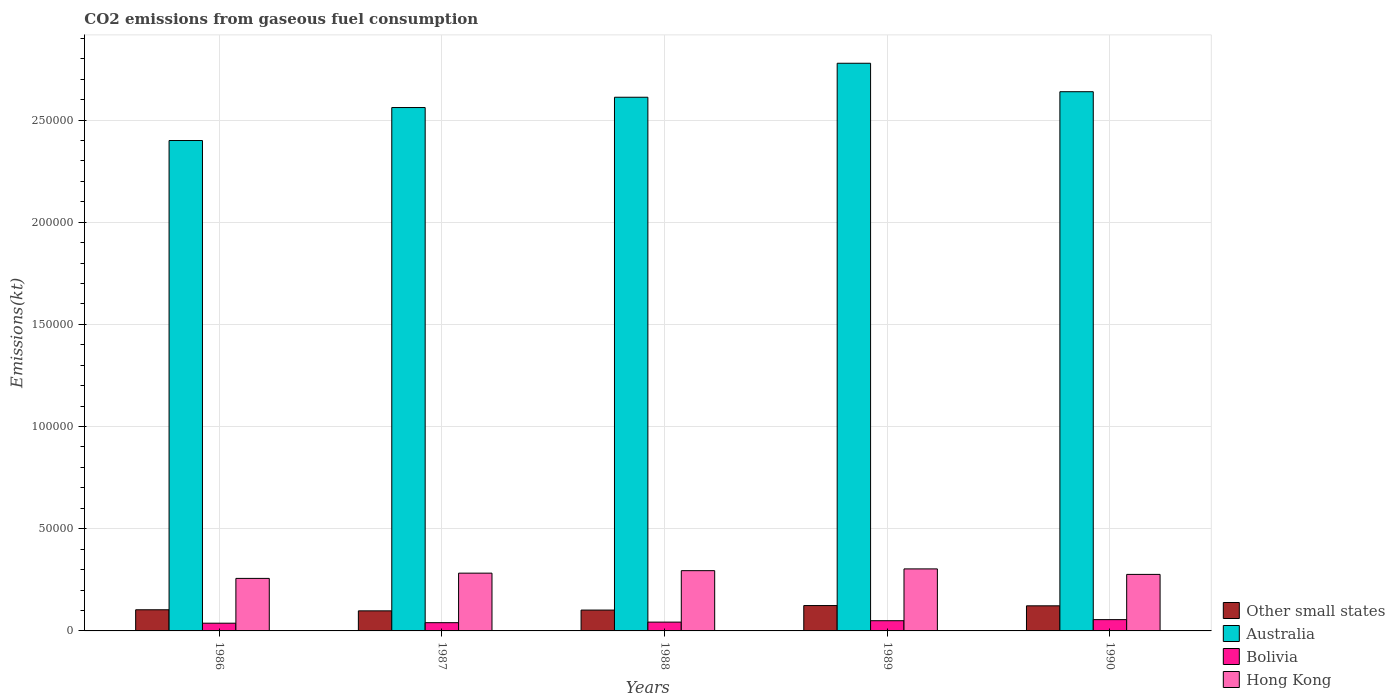How many bars are there on the 4th tick from the left?
Provide a short and direct response. 4. What is the label of the 3rd group of bars from the left?
Offer a very short reply. 1988. In how many cases, is the number of bars for a given year not equal to the number of legend labels?
Provide a short and direct response. 0. What is the amount of CO2 emitted in Bolivia in 1987?
Ensure brevity in your answer.  4030.03. Across all years, what is the maximum amount of CO2 emitted in Bolivia?
Your answer should be compact. 5526.17. Across all years, what is the minimum amount of CO2 emitted in Hong Kong?
Keep it short and to the point. 2.57e+04. In which year was the amount of CO2 emitted in Australia minimum?
Your answer should be compact. 1986. What is the total amount of CO2 emitted in Bolivia in the graph?
Provide a succinct answer. 2.26e+04. What is the difference between the amount of CO2 emitted in Australia in 1987 and that in 1989?
Provide a short and direct response. -2.17e+04. What is the difference between the amount of CO2 emitted in Bolivia in 1987 and the amount of CO2 emitted in Australia in 1989?
Offer a very short reply. -2.74e+05. What is the average amount of CO2 emitted in Australia per year?
Your response must be concise. 2.60e+05. In the year 1988, what is the difference between the amount of CO2 emitted in Australia and amount of CO2 emitted in Bolivia?
Offer a very short reply. 2.57e+05. In how many years, is the amount of CO2 emitted in Bolivia greater than 200000 kt?
Keep it short and to the point. 0. What is the ratio of the amount of CO2 emitted in Other small states in 1989 to that in 1990?
Provide a short and direct response. 1.01. What is the difference between the highest and the second highest amount of CO2 emitted in Australia?
Provide a succinct answer. 1.39e+04. What is the difference between the highest and the lowest amount of CO2 emitted in Australia?
Provide a succinct answer. 3.78e+04. Is it the case that in every year, the sum of the amount of CO2 emitted in Australia and amount of CO2 emitted in Other small states is greater than the sum of amount of CO2 emitted in Bolivia and amount of CO2 emitted in Hong Kong?
Your answer should be compact. Yes. What does the 1st bar from the left in 1987 represents?
Make the answer very short. Other small states. What does the 4th bar from the right in 1987 represents?
Provide a short and direct response. Other small states. Is it the case that in every year, the sum of the amount of CO2 emitted in Hong Kong and amount of CO2 emitted in Australia is greater than the amount of CO2 emitted in Bolivia?
Offer a terse response. Yes. Are all the bars in the graph horizontal?
Make the answer very short. No. What is the difference between two consecutive major ticks on the Y-axis?
Provide a short and direct response. 5.00e+04. Are the values on the major ticks of Y-axis written in scientific E-notation?
Provide a succinct answer. No. Does the graph contain any zero values?
Offer a terse response. No. Does the graph contain grids?
Offer a terse response. Yes. How many legend labels are there?
Make the answer very short. 4. How are the legend labels stacked?
Offer a very short reply. Vertical. What is the title of the graph?
Ensure brevity in your answer.  CO2 emissions from gaseous fuel consumption. Does "Indonesia" appear as one of the legend labels in the graph?
Keep it short and to the point. No. What is the label or title of the X-axis?
Give a very brief answer. Years. What is the label or title of the Y-axis?
Your answer should be very brief. Emissions(kt). What is the Emissions(kt) of Other small states in 1986?
Keep it short and to the point. 1.03e+04. What is the Emissions(kt) of Australia in 1986?
Your answer should be compact. 2.40e+05. What is the Emissions(kt) in Bolivia in 1986?
Your answer should be very brief. 3777.01. What is the Emissions(kt) of Hong Kong in 1986?
Give a very brief answer. 2.57e+04. What is the Emissions(kt) in Other small states in 1987?
Your answer should be very brief. 9817.71. What is the Emissions(kt) of Australia in 1987?
Offer a terse response. 2.56e+05. What is the Emissions(kt) of Bolivia in 1987?
Provide a succinct answer. 4030.03. What is the Emissions(kt) in Hong Kong in 1987?
Provide a succinct answer. 2.83e+04. What is the Emissions(kt) in Other small states in 1988?
Give a very brief answer. 1.02e+04. What is the Emissions(kt) of Australia in 1988?
Your answer should be very brief. 2.61e+05. What is the Emissions(kt) of Bolivia in 1988?
Offer a very short reply. 4308.73. What is the Emissions(kt) of Hong Kong in 1988?
Your answer should be very brief. 2.95e+04. What is the Emissions(kt) in Other small states in 1989?
Your answer should be compact. 1.24e+04. What is the Emissions(kt) of Australia in 1989?
Keep it short and to the point. 2.78e+05. What is the Emissions(kt) in Bolivia in 1989?
Your answer should be compact. 4994.45. What is the Emissions(kt) of Hong Kong in 1989?
Keep it short and to the point. 3.03e+04. What is the Emissions(kt) in Other small states in 1990?
Your answer should be very brief. 1.23e+04. What is the Emissions(kt) of Australia in 1990?
Your answer should be very brief. 2.64e+05. What is the Emissions(kt) of Bolivia in 1990?
Make the answer very short. 5526.17. What is the Emissions(kt) of Hong Kong in 1990?
Make the answer very short. 2.77e+04. Across all years, what is the maximum Emissions(kt) of Other small states?
Give a very brief answer. 1.24e+04. Across all years, what is the maximum Emissions(kt) in Australia?
Your answer should be very brief. 2.78e+05. Across all years, what is the maximum Emissions(kt) of Bolivia?
Offer a very short reply. 5526.17. Across all years, what is the maximum Emissions(kt) in Hong Kong?
Your answer should be very brief. 3.03e+04. Across all years, what is the minimum Emissions(kt) of Other small states?
Offer a very short reply. 9817.71. Across all years, what is the minimum Emissions(kt) in Australia?
Your answer should be compact. 2.40e+05. Across all years, what is the minimum Emissions(kt) in Bolivia?
Offer a very short reply. 3777.01. Across all years, what is the minimum Emissions(kt) in Hong Kong?
Offer a terse response. 2.57e+04. What is the total Emissions(kt) in Other small states in the graph?
Give a very brief answer. 5.51e+04. What is the total Emissions(kt) in Australia in the graph?
Keep it short and to the point. 1.30e+06. What is the total Emissions(kt) of Bolivia in the graph?
Make the answer very short. 2.26e+04. What is the total Emissions(kt) of Hong Kong in the graph?
Provide a succinct answer. 1.41e+05. What is the difference between the Emissions(kt) of Other small states in 1986 and that in 1987?
Make the answer very short. 529.41. What is the difference between the Emissions(kt) in Australia in 1986 and that in 1987?
Make the answer very short. -1.61e+04. What is the difference between the Emissions(kt) of Bolivia in 1986 and that in 1987?
Your answer should be very brief. -253.02. What is the difference between the Emissions(kt) of Hong Kong in 1986 and that in 1987?
Offer a terse response. -2574.23. What is the difference between the Emissions(kt) in Other small states in 1986 and that in 1988?
Your response must be concise. 146.34. What is the difference between the Emissions(kt) in Australia in 1986 and that in 1988?
Make the answer very short. -2.12e+04. What is the difference between the Emissions(kt) of Bolivia in 1986 and that in 1988?
Provide a succinct answer. -531.72. What is the difference between the Emissions(kt) in Hong Kong in 1986 and that in 1988?
Provide a short and direct response. -3784.34. What is the difference between the Emissions(kt) of Other small states in 1986 and that in 1989?
Your answer should be very brief. -2061.68. What is the difference between the Emissions(kt) of Australia in 1986 and that in 1989?
Offer a terse response. -3.78e+04. What is the difference between the Emissions(kt) in Bolivia in 1986 and that in 1989?
Keep it short and to the point. -1217.44. What is the difference between the Emissions(kt) of Hong Kong in 1986 and that in 1989?
Keep it short and to the point. -4649.76. What is the difference between the Emissions(kt) of Other small states in 1986 and that in 1990?
Keep it short and to the point. -1932.55. What is the difference between the Emissions(kt) of Australia in 1986 and that in 1990?
Your answer should be compact. -2.39e+04. What is the difference between the Emissions(kt) in Bolivia in 1986 and that in 1990?
Your answer should be very brief. -1749.16. What is the difference between the Emissions(kt) in Hong Kong in 1986 and that in 1990?
Make the answer very short. -1961.85. What is the difference between the Emissions(kt) in Other small states in 1987 and that in 1988?
Give a very brief answer. -383.07. What is the difference between the Emissions(kt) of Australia in 1987 and that in 1988?
Offer a very short reply. -5038.46. What is the difference between the Emissions(kt) of Bolivia in 1987 and that in 1988?
Your response must be concise. -278.69. What is the difference between the Emissions(kt) in Hong Kong in 1987 and that in 1988?
Ensure brevity in your answer.  -1210.11. What is the difference between the Emissions(kt) of Other small states in 1987 and that in 1989?
Keep it short and to the point. -2591.08. What is the difference between the Emissions(kt) in Australia in 1987 and that in 1989?
Give a very brief answer. -2.17e+04. What is the difference between the Emissions(kt) in Bolivia in 1987 and that in 1989?
Give a very brief answer. -964.42. What is the difference between the Emissions(kt) in Hong Kong in 1987 and that in 1989?
Your answer should be compact. -2075.52. What is the difference between the Emissions(kt) in Other small states in 1987 and that in 1990?
Your answer should be compact. -2461.96. What is the difference between the Emissions(kt) in Australia in 1987 and that in 1990?
Keep it short and to the point. -7741.04. What is the difference between the Emissions(kt) in Bolivia in 1987 and that in 1990?
Offer a terse response. -1496.14. What is the difference between the Emissions(kt) of Hong Kong in 1987 and that in 1990?
Your answer should be compact. 612.39. What is the difference between the Emissions(kt) in Other small states in 1988 and that in 1989?
Your response must be concise. -2208.02. What is the difference between the Emissions(kt) of Australia in 1988 and that in 1989?
Your answer should be very brief. -1.66e+04. What is the difference between the Emissions(kt) in Bolivia in 1988 and that in 1989?
Your response must be concise. -685.73. What is the difference between the Emissions(kt) of Hong Kong in 1988 and that in 1989?
Make the answer very short. -865.41. What is the difference between the Emissions(kt) in Other small states in 1988 and that in 1990?
Provide a short and direct response. -2078.89. What is the difference between the Emissions(kt) of Australia in 1988 and that in 1990?
Your answer should be very brief. -2702.58. What is the difference between the Emissions(kt) in Bolivia in 1988 and that in 1990?
Your response must be concise. -1217.44. What is the difference between the Emissions(kt) of Hong Kong in 1988 and that in 1990?
Give a very brief answer. 1822.5. What is the difference between the Emissions(kt) in Other small states in 1989 and that in 1990?
Provide a succinct answer. 129.12. What is the difference between the Emissions(kt) of Australia in 1989 and that in 1990?
Your answer should be compact. 1.39e+04. What is the difference between the Emissions(kt) in Bolivia in 1989 and that in 1990?
Your answer should be very brief. -531.72. What is the difference between the Emissions(kt) of Hong Kong in 1989 and that in 1990?
Your response must be concise. 2687.91. What is the difference between the Emissions(kt) of Other small states in 1986 and the Emissions(kt) of Australia in 1987?
Offer a very short reply. -2.46e+05. What is the difference between the Emissions(kt) in Other small states in 1986 and the Emissions(kt) in Bolivia in 1987?
Provide a short and direct response. 6317.08. What is the difference between the Emissions(kt) of Other small states in 1986 and the Emissions(kt) of Hong Kong in 1987?
Give a very brief answer. -1.79e+04. What is the difference between the Emissions(kt) in Australia in 1986 and the Emissions(kt) in Bolivia in 1987?
Make the answer very short. 2.36e+05. What is the difference between the Emissions(kt) of Australia in 1986 and the Emissions(kt) of Hong Kong in 1987?
Provide a short and direct response. 2.12e+05. What is the difference between the Emissions(kt) of Bolivia in 1986 and the Emissions(kt) of Hong Kong in 1987?
Keep it short and to the point. -2.45e+04. What is the difference between the Emissions(kt) of Other small states in 1986 and the Emissions(kt) of Australia in 1988?
Provide a succinct answer. -2.51e+05. What is the difference between the Emissions(kt) in Other small states in 1986 and the Emissions(kt) in Bolivia in 1988?
Your answer should be very brief. 6038.39. What is the difference between the Emissions(kt) in Other small states in 1986 and the Emissions(kt) in Hong Kong in 1988?
Keep it short and to the point. -1.91e+04. What is the difference between the Emissions(kt) in Australia in 1986 and the Emissions(kt) in Bolivia in 1988?
Make the answer very short. 2.36e+05. What is the difference between the Emissions(kt) of Australia in 1986 and the Emissions(kt) of Hong Kong in 1988?
Keep it short and to the point. 2.10e+05. What is the difference between the Emissions(kt) in Bolivia in 1986 and the Emissions(kt) in Hong Kong in 1988?
Provide a short and direct response. -2.57e+04. What is the difference between the Emissions(kt) in Other small states in 1986 and the Emissions(kt) in Australia in 1989?
Provide a short and direct response. -2.67e+05. What is the difference between the Emissions(kt) of Other small states in 1986 and the Emissions(kt) of Bolivia in 1989?
Ensure brevity in your answer.  5352.66. What is the difference between the Emissions(kt) in Other small states in 1986 and the Emissions(kt) in Hong Kong in 1989?
Ensure brevity in your answer.  -2.00e+04. What is the difference between the Emissions(kt) in Australia in 1986 and the Emissions(kt) in Bolivia in 1989?
Ensure brevity in your answer.  2.35e+05. What is the difference between the Emissions(kt) in Australia in 1986 and the Emissions(kt) in Hong Kong in 1989?
Your answer should be compact. 2.10e+05. What is the difference between the Emissions(kt) in Bolivia in 1986 and the Emissions(kt) in Hong Kong in 1989?
Your answer should be compact. -2.66e+04. What is the difference between the Emissions(kt) in Other small states in 1986 and the Emissions(kt) in Australia in 1990?
Your response must be concise. -2.54e+05. What is the difference between the Emissions(kt) of Other small states in 1986 and the Emissions(kt) of Bolivia in 1990?
Your answer should be compact. 4820.95. What is the difference between the Emissions(kt) in Other small states in 1986 and the Emissions(kt) in Hong Kong in 1990?
Your response must be concise. -1.73e+04. What is the difference between the Emissions(kt) of Australia in 1986 and the Emissions(kt) of Bolivia in 1990?
Offer a terse response. 2.34e+05. What is the difference between the Emissions(kt) in Australia in 1986 and the Emissions(kt) in Hong Kong in 1990?
Keep it short and to the point. 2.12e+05. What is the difference between the Emissions(kt) in Bolivia in 1986 and the Emissions(kt) in Hong Kong in 1990?
Your answer should be very brief. -2.39e+04. What is the difference between the Emissions(kt) in Other small states in 1987 and the Emissions(kt) in Australia in 1988?
Give a very brief answer. -2.51e+05. What is the difference between the Emissions(kt) of Other small states in 1987 and the Emissions(kt) of Bolivia in 1988?
Ensure brevity in your answer.  5508.98. What is the difference between the Emissions(kt) of Other small states in 1987 and the Emissions(kt) of Hong Kong in 1988?
Provide a short and direct response. -1.97e+04. What is the difference between the Emissions(kt) in Australia in 1987 and the Emissions(kt) in Bolivia in 1988?
Keep it short and to the point. 2.52e+05. What is the difference between the Emissions(kt) in Australia in 1987 and the Emissions(kt) in Hong Kong in 1988?
Ensure brevity in your answer.  2.27e+05. What is the difference between the Emissions(kt) in Bolivia in 1987 and the Emissions(kt) in Hong Kong in 1988?
Your answer should be compact. -2.55e+04. What is the difference between the Emissions(kt) of Other small states in 1987 and the Emissions(kt) of Australia in 1989?
Provide a short and direct response. -2.68e+05. What is the difference between the Emissions(kt) of Other small states in 1987 and the Emissions(kt) of Bolivia in 1989?
Offer a very short reply. 4823.26. What is the difference between the Emissions(kt) in Other small states in 1987 and the Emissions(kt) in Hong Kong in 1989?
Your answer should be compact. -2.05e+04. What is the difference between the Emissions(kt) of Australia in 1987 and the Emissions(kt) of Bolivia in 1989?
Your response must be concise. 2.51e+05. What is the difference between the Emissions(kt) of Australia in 1987 and the Emissions(kt) of Hong Kong in 1989?
Your answer should be compact. 2.26e+05. What is the difference between the Emissions(kt) in Bolivia in 1987 and the Emissions(kt) in Hong Kong in 1989?
Your answer should be very brief. -2.63e+04. What is the difference between the Emissions(kt) in Other small states in 1987 and the Emissions(kt) in Australia in 1990?
Offer a very short reply. -2.54e+05. What is the difference between the Emissions(kt) in Other small states in 1987 and the Emissions(kt) in Bolivia in 1990?
Make the answer very short. 4291.54. What is the difference between the Emissions(kt) in Other small states in 1987 and the Emissions(kt) in Hong Kong in 1990?
Your response must be concise. -1.78e+04. What is the difference between the Emissions(kt) of Australia in 1987 and the Emissions(kt) of Bolivia in 1990?
Offer a terse response. 2.51e+05. What is the difference between the Emissions(kt) in Australia in 1987 and the Emissions(kt) in Hong Kong in 1990?
Give a very brief answer. 2.28e+05. What is the difference between the Emissions(kt) in Bolivia in 1987 and the Emissions(kt) in Hong Kong in 1990?
Your response must be concise. -2.36e+04. What is the difference between the Emissions(kt) in Other small states in 1988 and the Emissions(kt) in Australia in 1989?
Offer a very short reply. -2.68e+05. What is the difference between the Emissions(kt) in Other small states in 1988 and the Emissions(kt) in Bolivia in 1989?
Your response must be concise. 5206.32. What is the difference between the Emissions(kt) in Other small states in 1988 and the Emissions(kt) in Hong Kong in 1989?
Your answer should be very brief. -2.01e+04. What is the difference between the Emissions(kt) in Australia in 1988 and the Emissions(kt) in Bolivia in 1989?
Provide a succinct answer. 2.56e+05. What is the difference between the Emissions(kt) of Australia in 1988 and the Emissions(kt) of Hong Kong in 1989?
Make the answer very short. 2.31e+05. What is the difference between the Emissions(kt) in Bolivia in 1988 and the Emissions(kt) in Hong Kong in 1989?
Ensure brevity in your answer.  -2.60e+04. What is the difference between the Emissions(kt) in Other small states in 1988 and the Emissions(kt) in Australia in 1990?
Offer a very short reply. -2.54e+05. What is the difference between the Emissions(kt) of Other small states in 1988 and the Emissions(kt) of Bolivia in 1990?
Provide a succinct answer. 4674.61. What is the difference between the Emissions(kt) in Other small states in 1988 and the Emissions(kt) in Hong Kong in 1990?
Provide a short and direct response. -1.75e+04. What is the difference between the Emissions(kt) in Australia in 1988 and the Emissions(kt) in Bolivia in 1990?
Provide a succinct answer. 2.56e+05. What is the difference between the Emissions(kt) of Australia in 1988 and the Emissions(kt) of Hong Kong in 1990?
Your answer should be compact. 2.33e+05. What is the difference between the Emissions(kt) of Bolivia in 1988 and the Emissions(kt) of Hong Kong in 1990?
Make the answer very short. -2.34e+04. What is the difference between the Emissions(kt) of Other small states in 1989 and the Emissions(kt) of Australia in 1990?
Your answer should be compact. -2.51e+05. What is the difference between the Emissions(kt) in Other small states in 1989 and the Emissions(kt) in Bolivia in 1990?
Give a very brief answer. 6882.62. What is the difference between the Emissions(kt) of Other small states in 1989 and the Emissions(kt) of Hong Kong in 1990?
Offer a very short reply. -1.53e+04. What is the difference between the Emissions(kt) of Australia in 1989 and the Emissions(kt) of Bolivia in 1990?
Provide a short and direct response. 2.72e+05. What is the difference between the Emissions(kt) of Australia in 1989 and the Emissions(kt) of Hong Kong in 1990?
Provide a succinct answer. 2.50e+05. What is the difference between the Emissions(kt) of Bolivia in 1989 and the Emissions(kt) of Hong Kong in 1990?
Offer a terse response. -2.27e+04. What is the average Emissions(kt) of Other small states per year?
Make the answer very short. 1.10e+04. What is the average Emissions(kt) of Australia per year?
Keep it short and to the point. 2.60e+05. What is the average Emissions(kt) of Bolivia per year?
Provide a succinct answer. 4527.28. What is the average Emissions(kt) of Hong Kong per year?
Make the answer very short. 2.83e+04. In the year 1986, what is the difference between the Emissions(kt) in Other small states and Emissions(kt) in Australia?
Provide a succinct answer. -2.30e+05. In the year 1986, what is the difference between the Emissions(kt) of Other small states and Emissions(kt) of Bolivia?
Give a very brief answer. 6570.11. In the year 1986, what is the difference between the Emissions(kt) of Other small states and Emissions(kt) of Hong Kong?
Make the answer very short. -1.54e+04. In the year 1986, what is the difference between the Emissions(kt) in Australia and Emissions(kt) in Bolivia?
Your response must be concise. 2.36e+05. In the year 1986, what is the difference between the Emissions(kt) of Australia and Emissions(kt) of Hong Kong?
Give a very brief answer. 2.14e+05. In the year 1986, what is the difference between the Emissions(kt) in Bolivia and Emissions(kt) in Hong Kong?
Provide a succinct answer. -2.19e+04. In the year 1987, what is the difference between the Emissions(kt) of Other small states and Emissions(kt) of Australia?
Offer a very short reply. -2.46e+05. In the year 1987, what is the difference between the Emissions(kt) in Other small states and Emissions(kt) in Bolivia?
Your answer should be very brief. 5787.68. In the year 1987, what is the difference between the Emissions(kt) of Other small states and Emissions(kt) of Hong Kong?
Your response must be concise. -1.85e+04. In the year 1987, what is the difference between the Emissions(kt) of Australia and Emissions(kt) of Bolivia?
Your response must be concise. 2.52e+05. In the year 1987, what is the difference between the Emissions(kt) in Australia and Emissions(kt) in Hong Kong?
Your response must be concise. 2.28e+05. In the year 1987, what is the difference between the Emissions(kt) in Bolivia and Emissions(kt) in Hong Kong?
Give a very brief answer. -2.42e+04. In the year 1988, what is the difference between the Emissions(kt) in Other small states and Emissions(kt) in Australia?
Give a very brief answer. -2.51e+05. In the year 1988, what is the difference between the Emissions(kt) in Other small states and Emissions(kt) in Bolivia?
Your response must be concise. 5892.05. In the year 1988, what is the difference between the Emissions(kt) in Other small states and Emissions(kt) in Hong Kong?
Offer a terse response. -1.93e+04. In the year 1988, what is the difference between the Emissions(kt) in Australia and Emissions(kt) in Bolivia?
Make the answer very short. 2.57e+05. In the year 1988, what is the difference between the Emissions(kt) in Australia and Emissions(kt) in Hong Kong?
Provide a short and direct response. 2.32e+05. In the year 1988, what is the difference between the Emissions(kt) in Bolivia and Emissions(kt) in Hong Kong?
Keep it short and to the point. -2.52e+04. In the year 1989, what is the difference between the Emissions(kt) of Other small states and Emissions(kt) of Australia?
Offer a terse response. -2.65e+05. In the year 1989, what is the difference between the Emissions(kt) in Other small states and Emissions(kt) in Bolivia?
Your response must be concise. 7414.34. In the year 1989, what is the difference between the Emissions(kt) in Other small states and Emissions(kt) in Hong Kong?
Offer a very short reply. -1.79e+04. In the year 1989, what is the difference between the Emissions(kt) in Australia and Emissions(kt) in Bolivia?
Offer a terse response. 2.73e+05. In the year 1989, what is the difference between the Emissions(kt) in Australia and Emissions(kt) in Hong Kong?
Your answer should be compact. 2.47e+05. In the year 1989, what is the difference between the Emissions(kt) of Bolivia and Emissions(kt) of Hong Kong?
Your answer should be compact. -2.54e+04. In the year 1990, what is the difference between the Emissions(kt) of Other small states and Emissions(kt) of Australia?
Keep it short and to the point. -2.52e+05. In the year 1990, what is the difference between the Emissions(kt) of Other small states and Emissions(kt) of Bolivia?
Offer a terse response. 6753.5. In the year 1990, what is the difference between the Emissions(kt) in Other small states and Emissions(kt) in Hong Kong?
Provide a short and direct response. -1.54e+04. In the year 1990, what is the difference between the Emissions(kt) of Australia and Emissions(kt) of Bolivia?
Make the answer very short. 2.58e+05. In the year 1990, what is the difference between the Emissions(kt) in Australia and Emissions(kt) in Hong Kong?
Your response must be concise. 2.36e+05. In the year 1990, what is the difference between the Emissions(kt) in Bolivia and Emissions(kt) in Hong Kong?
Provide a succinct answer. -2.21e+04. What is the ratio of the Emissions(kt) in Other small states in 1986 to that in 1987?
Provide a short and direct response. 1.05. What is the ratio of the Emissions(kt) in Australia in 1986 to that in 1987?
Offer a terse response. 0.94. What is the ratio of the Emissions(kt) of Bolivia in 1986 to that in 1987?
Your response must be concise. 0.94. What is the ratio of the Emissions(kt) of Hong Kong in 1986 to that in 1987?
Make the answer very short. 0.91. What is the ratio of the Emissions(kt) of Other small states in 1986 to that in 1988?
Your response must be concise. 1.01. What is the ratio of the Emissions(kt) in Australia in 1986 to that in 1988?
Ensure brevity in your answer.  0.92. What is the ratio of the Emissions(kt) of Bolivia in 1986 to that in 1988?
Your answer should be very brief. 0.88. What is the ratio of the Emissions(kt) of Hong Kong in 1986 to that in 1988?
Give a very brief answer. 0.87. What is the ratio of the Emissions(kt) of Other small states in 1986 to that in 1989?
Offer a very short reply. 0.83. What is the ratio of the Emissions(kt) of Australia in 1986 to that in 1989?
Make the answer very short. 0.86. What is the ratio of the Emissions(kt) in Bolivia in 1986 to that in 1989?
Your answer should be very brief. 0.76. What is the ratio of the Emissions(kt) of Hong Kong in 1986 to that in 1989?
Offer a terse response. 0.85. What is the ratio of the Emissions(kt) in Other small states in 1986 to that in 1990?
Offer a very short reply. 0.84. What is the ratio of the Emissions(kt) of Australia in 1986 to that in 1990?
Your answer should be compact. 0.91. What is the ratio of the Emissions(kt) of Bolivia in 1986 to that in 1990?
Give a very brief answer. 0.68. What is the ratio of the Emissions(kt) of Hong Kong in 1986 to that in 1990?
Your answer should be very brief. 0.93. What is the ratio of the Emissions(kt) in Other small states in 1987 to that in 1988?
Offer a very short reply. 0.96. What is the ratio of the Emissions(kt) in Australia in 1987 to that in 1988?
Provide a short and direct response. 0.98. What is the ratio of the Emissions(kt) in Bolivia in 1987 to that in 1988?
Provide a short and direct response. 0.94. What is the ratio of the Emissions(kt) in Hong Kong in 1987 to that in 1988?
Offer a very short reply. 0.96. What is the ratio of the Emissions(kt) in Other small states in 1987 to that in 1989?
Your answer should be compact. 0.79. What is the ratio of the Emissions(kt) in Australia in 1987 to that in 1989?
Ensure brevity in your answer.  0.92. What is the ratio of the Emissions(kt) in Bolivia in 1987 to that in 1989?
Your answer should be compact. 0.81. What is the ratio of the Emissions(kt) of Hong Kong in 1987 to that in 1989?
Provide a succinct answer. 0.93. What is the ratio of the Emissions(kt) in Other small states in 1987 to that in 1990?
Your answer should be compact. 0.8. What is the ratio of the Emissions(kt) in Australia in 1987 to that in 1990?
Offer a terse response. 0.97. What is the ratio of the Emissions(kt) in Bolivia in 1987 to that in 1990?
Make the answer very short. 0.73. What is the ratio of the Emissions(kt) of Hong Kong in 1987 to that in 1990?
Offer a terse response. 1.02. What is the ratio of the Emissions(kt) of Other small states in 1988 to that in 1989?
Keep it short and to the point. 0.82. What is the ratio of the Emissions(kt) of Australia in 1988 to that in 1989?
Make the answer very short. 0.94. What is the ratio of the Emissions(kt) in Bolivia in 1988 to that in 1989?
Ensure brevity in your answer.  0.86. What is the ratio of the Emissions(kt) of Hong Kong in 1988 to that in 1989?
Keep it short and to the point. 0.97. What is the ratio of the Emissions(kt) in Other small states in 1988 to that in 1990?
Your response must be concise. 0.83. What is the ratio of the Emissions(kt) in Australia in 1988 to that in 1990?
Offer a terse response. 0.99. What is the ratio of the Emissions(kt) of Bolivia in 1988 to that in 1990?
Ensure brevity in your answer.  0.78. What is the ratio of the Emissions(kt) in Hong Kong in 1988 to that in 1990?
Your response must be concise. 1.07. What is the ratio of the Emissions(kt) in Other small states in 1989 to that in 1990?
Provide a succinct answer. 1.01. What is the ratio of the Emissions(kt) of Australia in 1989 to that in 1990?
Provide a short and direct response. 1.05. What is the ratio of the Emissions(kt) in Bolivia in 1989 to that in 1990?
Your answer should be very brief. 0.9. What is the ratio of the Emissions(kt) in Hong Kong in 1989 to that in 1990?
Your answer should be very brief. 1.1. What is the difference between the highest and the second highest Emissions(kt) of Other small states?
Your answer should be compact. 129.12. What is the difference between the highest and the second highest Emissions(kt) in Australia?
Your answer should be very brief. 1.39e+04. What is the difference between the highest and the second highest Emissions(kt) in Bolivia?
Offer a terse response. 531.72. What is the difference between the highest and the second highest Emissions(kt) in Hong Kong?
Your answer should be compact. 865.41. What is the difference between the highest and the lowest Emissions(kt) of Other small states?
Ensure brevity in your answer.  2591.08. What is the difference between the highest and the lowest Emissions(kt) in Australia?
Make the answer very short. 3.78e+04. What is the difference between the highest and the lowest Emissions(kt) in Bolivia?
Ensure brevity in your answer.  1749.16. What is the difference between the highest and the lowest Emissions(kt) in Hong Kong?
Offer a terse response. 4649.76. 